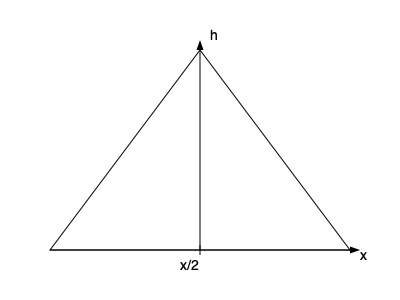As a Christmas tree farmer, you want to optimize the spacing between rows of trees in a triangular planting pattern. If the height of the triangle (h) is 20 meters and you want to maximize the number of trees while ensuring each tree has at least 4 square meters of growing space, what is the optimal distance (x) between rows? Let's approach this step-by-step:

1) In a triangular pattern, each tree occupies a rhombus-shaped area. The area of this rhombus is the product of the distance between rows (x) and the distance between trees in a row (which is x/2).

2) Area of rhombus = $x \cdot \frac{x}{2} = \frac{x^2}{2}$

3) We want this area to be at least 4 square meters:

   $\frac{x^2}{2} \geq 4$

4) Solving for x:
   $x^2 \geq 8$
   $x \geq \sqrt{8} = 2\sqrt{2} \approx 2.83$ meters

5) Now, we need to find how many rows we can fit in the 20-meter height:

   Number of rows = $\frac{h}{x} = \frac{20}{x}$

6) The total number of trees will be proportional to:

   $\frac{20}{x} \cdot \frac{2}{x} = \frac{40}{x^2}$

7) To maximize this, we want x to be as small as possible while still satisfying $x \geq 2\sqrt{2}$.

8) Therefore, the optimal distance is $x = 2\sqrt{2}$ meters.
Answer: $2\sqrt{2}$ meters 